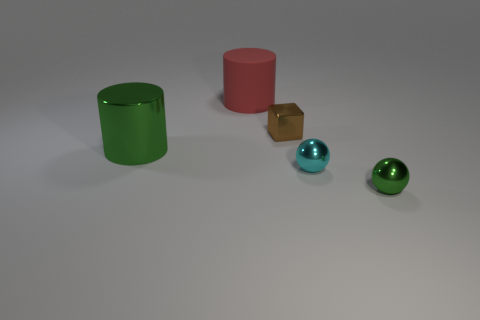Is there anything else that has the same material as the big red cylinder?
Give a very brief answer. No. There is another red cylinder that is the same size as the metallic cylinder; what is its material?
Your answer should be compact. Rubber. There is a brown metal object that is the same size as the green metallic sphere; what shape is it?
Provide a succinct answer. Cube. There is a large green object that is the same material as the small block; what shape is it?
Give a very brief answer. Cylinder. Is there any other thing that has the same shape as the big green metallic object?
Your response must be concise. Yes. What number of green metal objects are on the left side of the small brown metallic object?
Offer a very short reply. 1. Are any large brown cylinders visible?
Offer a very short reply. No. There is a cylinder that is in front of the tiny object behind the metal object left of the big matte thing; what color is it?
Keep it short and to the point. Green. Is there a tiny brown metal thing that is in front of the green metal object in front of the big shiny thing?
Give a very brief answer. No. Does the object that is behind the brown cube have the same color as the large thing to the left of the large red rubber object?
Your answer should be compact. No. 